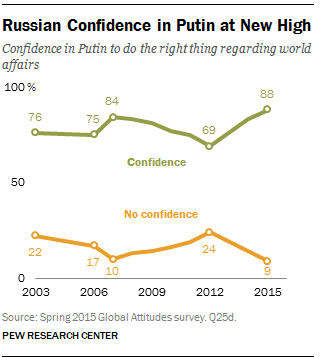Point out several critical features in this image. In 2015, there were fewer data points compared to 2019. Specifically, in 2015, there were 79 data points, while in 2019, there were 145 data points. Based on the graph, it can be concluded that people have more confidence than no confidence in the market. Confidence in the market has been steadily increasing since 2020. However, there were periods of uncertainty and decreased confidence in 2021 and 2022, particularly in the first quarter of 2021. Nevertheless, the overall trend indicates that people have more confidence in the market compared to no confidence. 